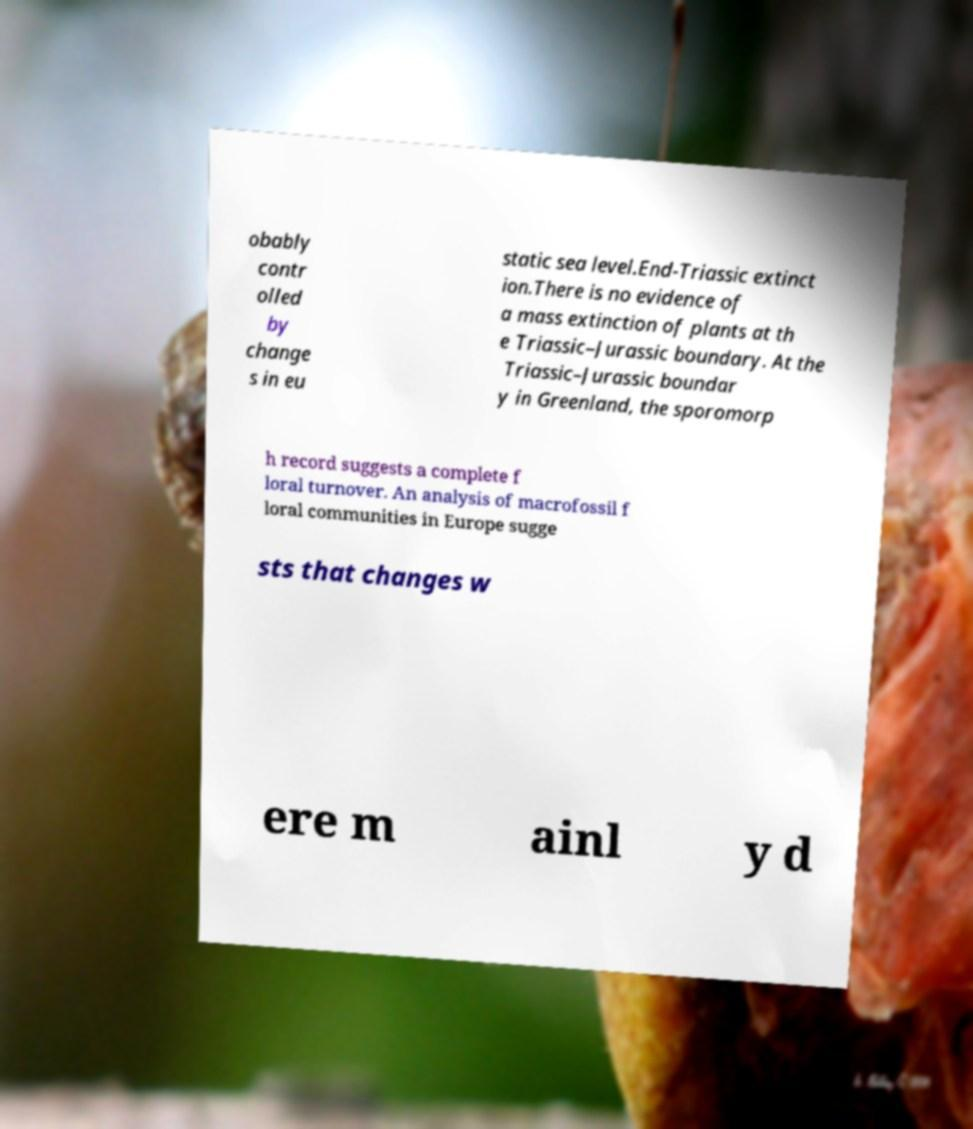For documentation purposes, I need the text within this image transcribed. Could you provide that? obably contr olled by change s in eu static sea level.End-Triassic extinct ion.There is no evidence of a mass extinction of plants at th e Triassic–Jurassic boundary. At the Triassic–Jurassic boundar y in Greenland, the sporomorp h record suggests a complete f loral turnover. An analysis of macrofossil f loral communities in Europe sugge sts that changes w ere m ainl y d 